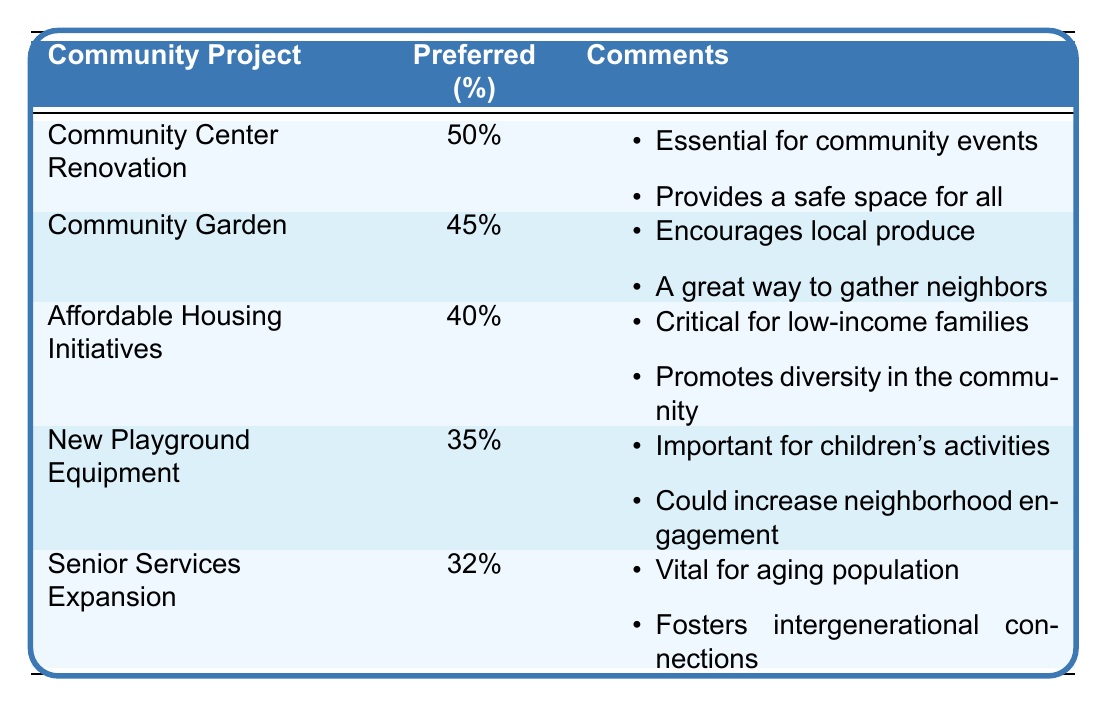What is the community project with the highest preferred percentage? The table shows that "Community Center Renovation" has the highest preferred percentage of 50%.
Answer: Community Center Renovation Which community project received a preferred percentage of 35%? According to the table, "New Playground Equipment" has a preferred percentage of 35%.
Answer: New Playground Equipment Is the preferred percentage for "Bike Lanes Expansion" higher than 30%? The table states that "Bike Lanes Expansion" has a preferred percentage of 28%, which is lower than 30%.
Answer: No What is the difference in preferred percentage between "Community Center Renovation" and "Public Art Installations"? "Community Center Renovation" has a preferred percentage of 50%, while "Public Art Installations" has 25%. The difference is 50 - 25 = 25%.
Answer: 25% What is the average preferred percentage for all the projects listed in the table? The total preferred percentages are 50 + 45 + 40 + 35 + 32 + 30 + 28 + 25 = 315. There are 8 projects, so the average is 315 / 8 = 39.375%.
Answer: 39.375% Which community project has comments indicating it promotes diversity in the community? The table shows that "Affordable Housing Initiatives" has comments stating that it promotes diversity in the community.
Answer: Affordable Housing Initiatives How many community projects have a preferred percentage of 30% or higher? There are five projects with preferred percentages of 30% or higher: "Community Center Renovation" (50%), "Community Garden" (45%), "Affordable Housing Initiatives" (40%), "New Playground Equipment" (35%), and "Senior Services Expansion" (32%).
Answer: 5 Which project is considered essential for community events? The comments for "Community Center Renovation" indicate it is considered essential for community events.
Answer: Community Center Renovation What project received the lowest preferred percentage among the listed initiatives? The lowest preferred percentage in the table is for "Bike Lanes Expansion" with 28%.
Answer: Bike Lanes Expansion Is there a community project that encourages local produce? Yes, "Community Garden" is indicated in the comments to encourage local produce.
Answer: Yes If you combine the preferred percentages of "New Playground Equipment" and "Transportation Improvements," what would be the total? "New Playground Equipment" has a preferred percentage of 35%, and "Transportation Improvements" has 30%. The total is 35 + 30 = 65%.
Answer: 65% 